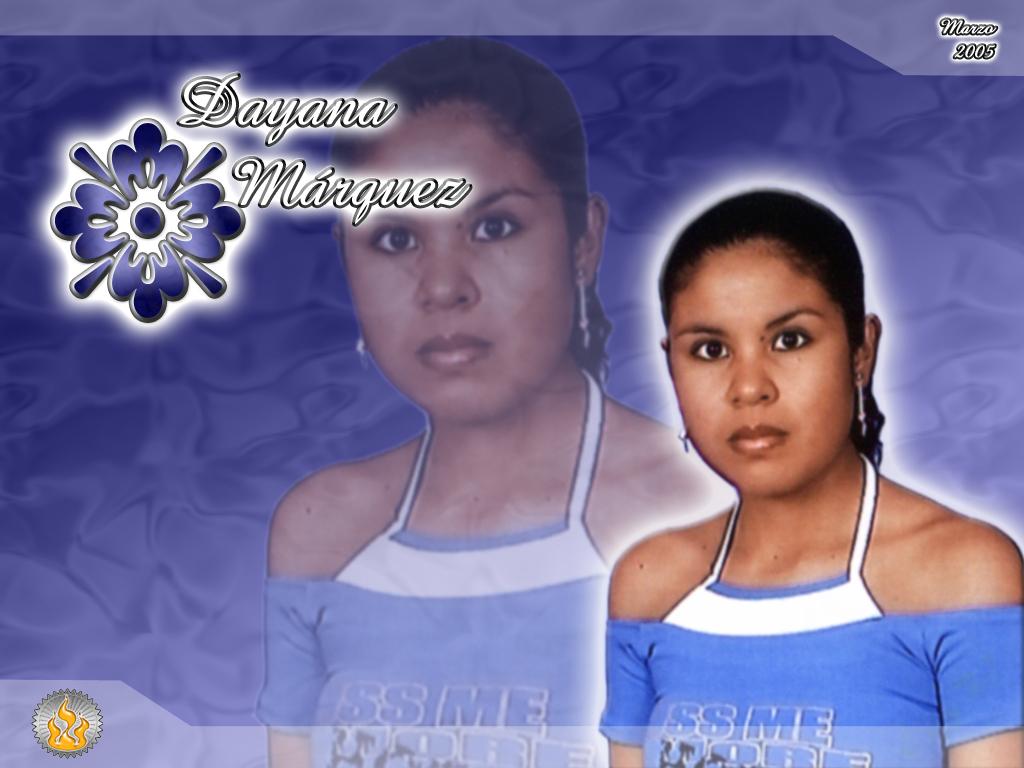What year was the picture taken?
Your response must be concise. 2005. 